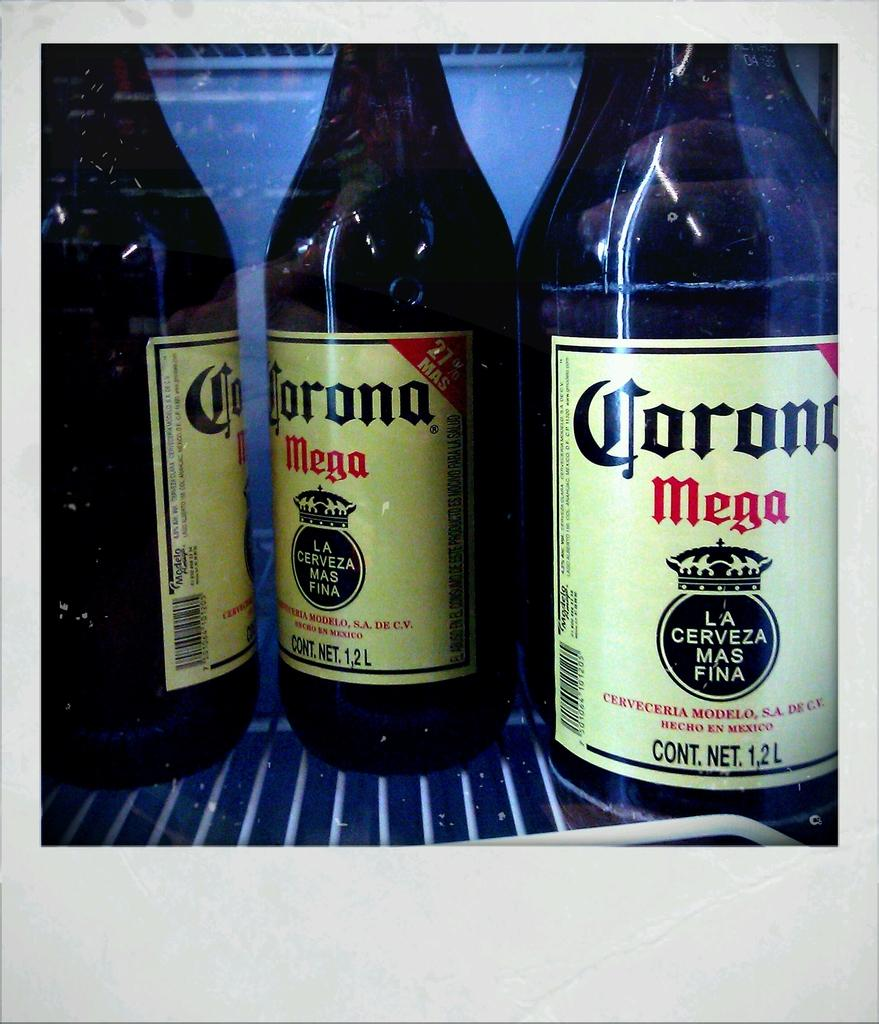<image>
Give a short and clear explanation of the subsequent image. three large brown bottle of corona mega beer 